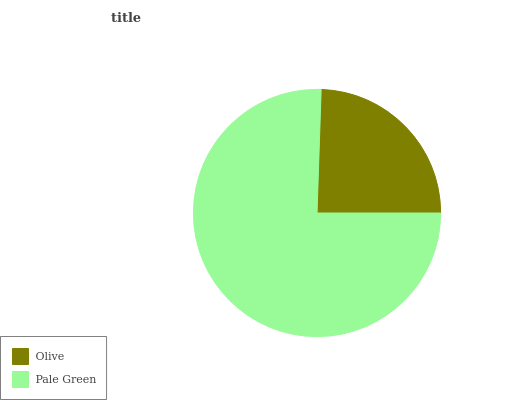Is Olive the minimum?
Answer yes or no. Yes. Is Pale Green the maximum?
Answer yes or no. Yes. Is Pale Green the minimum?
Answer yes or no. No. Is Pale Green greater than Olive?
Answer yes or no. Yes. Is Olive less than Pale Green?
Answer yes or no. Yes. Is Olive greater than Pale Green?
Answer yes or no. No. Is Pale Green less than Olive?
Answer yes or no. No. Is Pale Green the high median?
Answer yes or no. Yes. Is Olive the low median?
Answer yes or no. Yes. Is Olive the high median?
Answer yes or no. No. Is Pale Green the low median?
Answer yes or no. No. 